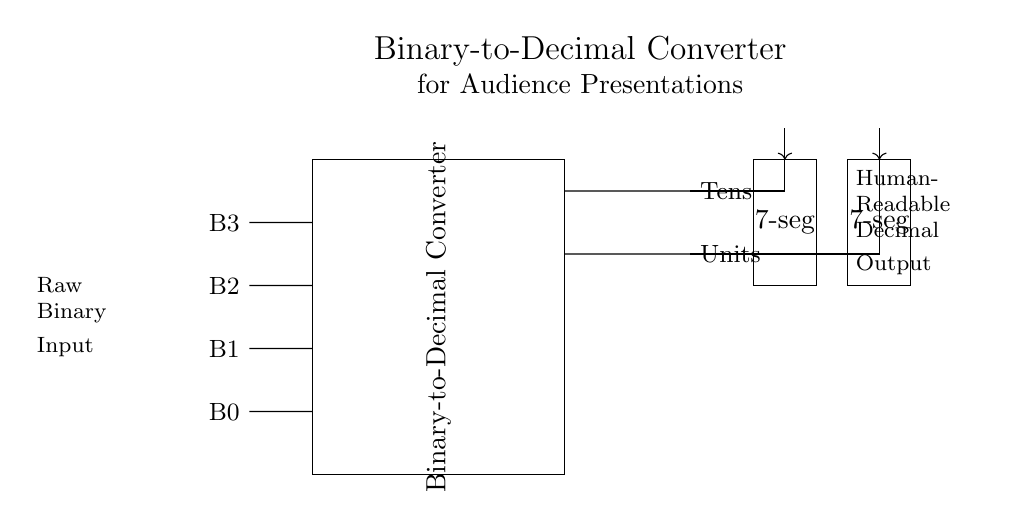What are the binary inputs for this circuit? The binary inputs are labeled B3, B2, B1, and B0. They are the four input lines representing binary digits, each corresponding to a bit in the binary number.
Answer: B3, B2, B1, B0 What does the output represent? The output of the circuit has two components labeled Tens and Units, representing the decimal values derived from the binary inputs based on their positions in the binary number.
Answer: Decimal values What type of circuit is this? This is a binary-to-decimal converter circuit, specifically designed to translate binary input signals into human-readable decimal output.
Answer: Binary-to-decimal converter How many 7-segment displays are present in this circuit? The circuit shows two 7-segment displays, one for the Tens place and another for the Units place of the decimal output.
Answer: Two What is the primary function of the Binary-to-Decimal Converter? The primary function is to take binary input and convert it to its equivalent decimal representation, allowing easier interpretation for humans.
Answer: Convert binary to decimal What do you connect to the inputs B3, B2, B1, and B0? The inputs should be connected to the binary data signals that represent a binary number intended for conversion to decimal.
Answer: Binary data signals Which signal is routed to the 7-segment display for Tens? The Tens output from the converter circuit is routed to the first 7-segment display, which shows the tens digit of the decimal value.
Answer: Tens output 